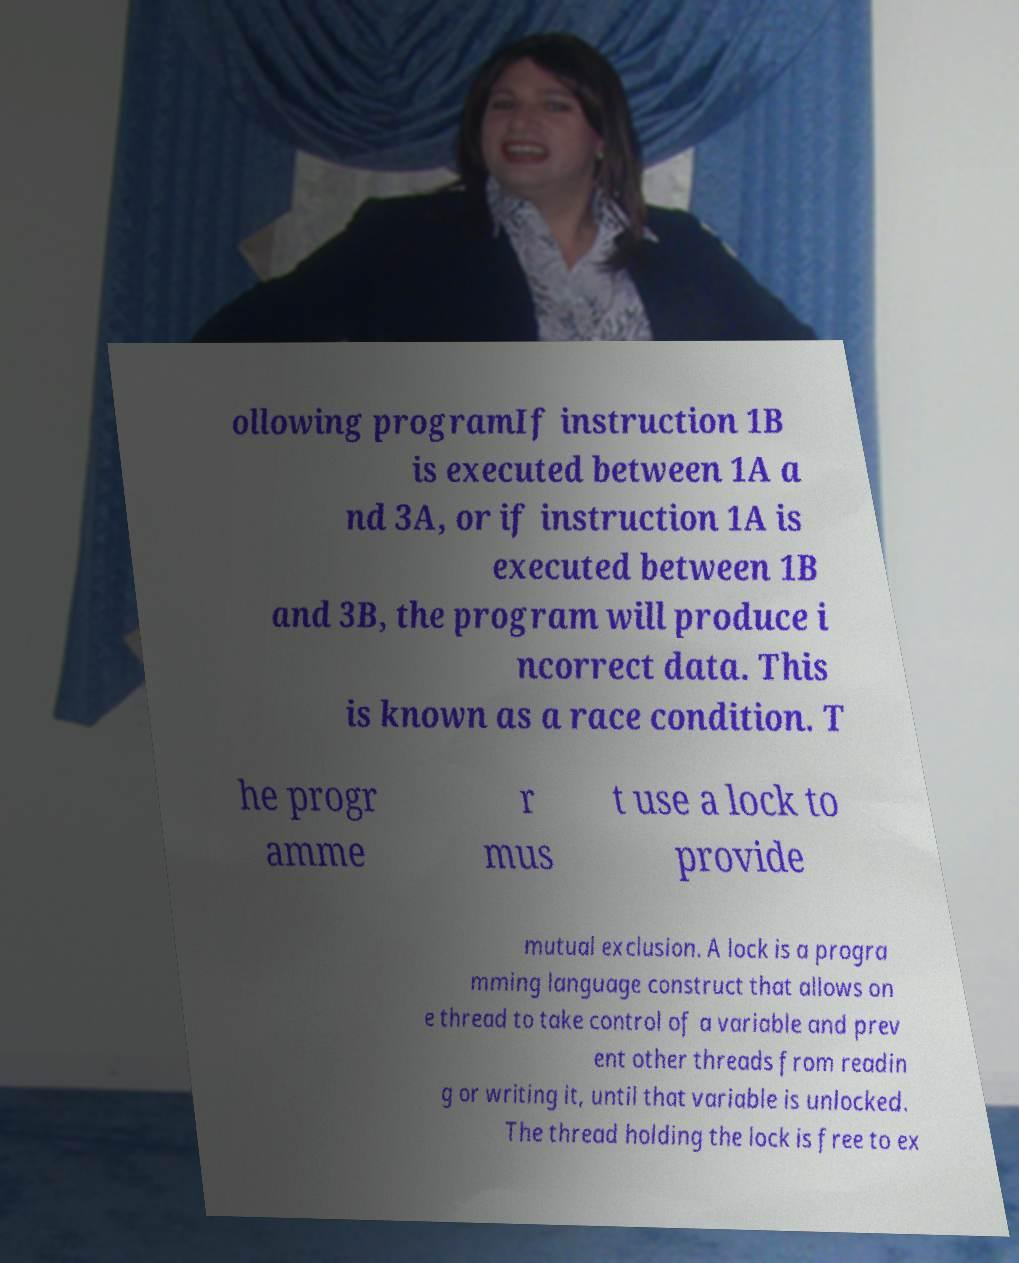Could you extract and type out the text from this image? ollowing programIf instruction 1B is executed between 1A a nd 3A, or if instruction 1A is executed between 1B and 3B, the program will produce i ncorrect data. This is known as a race condition. T he progr amme r mus t use a lock to provide mutual exclusion. A lock is a progra mming language construct that allows on e thread to take control of a variable and prev ent other threads from readin g or writing it, until that variable is unlocked. The thread holding the lock is free to ex 